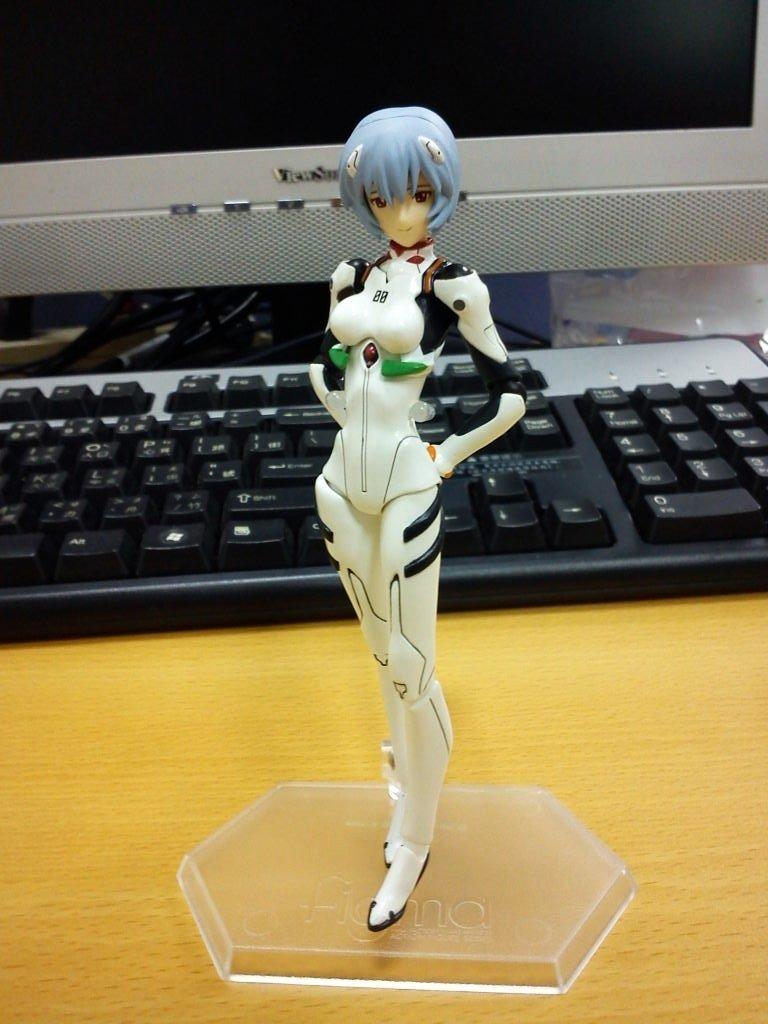Can you describe this image briefly? In this image we can see one toy on the wooden table, some objects on the table, one computer with wires and keyboard on the table. 